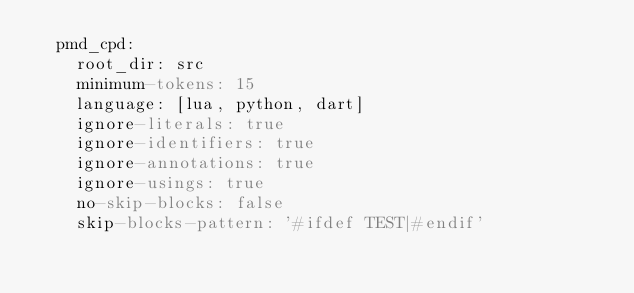<code> <loc_0><loc_0><loc_500><loc_500><_YAML_>  pmd_cpd:
    root_dir: src
    minimum-tokens: 15
    language: [lua, python, dart]
    ignore-literals: true
    ignore-identifiers: true
    ignore-annotations: true
    ignore-usings: true
    no-skip-blocks: false
    skip-blocks-pattern: '#ifdef TEST|#endif'
</code> 